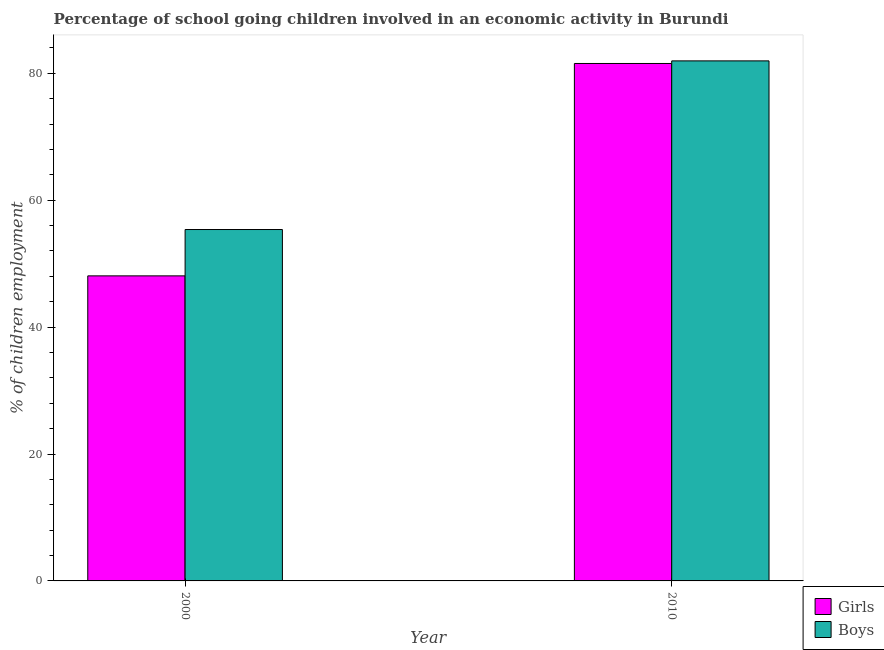How many different coloured bars are there?
Offer a terse response. 2. How many groups of bars are there?
Your answer should be very brief. 2. Are the number of bars on each tick of the X-axis equal?
Your response must be concise. Yes. How many bars are there on the 2nd tick from the left?
Give a very brief answer. 2. In how many cases, is the number of bars for a given year not equal to the number of legend labels?
Ensure brevity in your answer.  0. What is the percentage of school going boys in 2000?
Give a very brief answer. 55.38. Across all years, what is the maximum percentage of school going girls?
Make the answer very short. 81.54. Across all years, what is the minimum percentage of school going boys?
Offer a terse response. 55.38. What is the total percentage of school going boys in the graph?
Your response must be concise. 137.33. What is the difference between the percentage of school going girls in 2000 and that in 2010?
Your answer should be compact. -33.47. What is the difference between the percentage of school going boys in 2010 and the percentage of school going girls in 2000?
Your response must be concise. 26.58. What is the average percentage of school going girls per year?
Offer a terse response. 64.81. In how many years, is the percentage of school going girls greater than 44 %?
Provide a succinct answer. 2. What is the ratio of the percentage of school going girls in 2000 to that in 2010?
Your answer should be very brief. 0.59. What does the 1st bar from the left in 2000 represents?
Provide a short and direct response. Girls. What does the 2nd bar from the right in 2010 represents?
Offer a terse response. Girls. How many bars are there?
Offer a very short reply. 4. How many years are there in the graph?
Ensure brevity in your answer.  2. Are the values on the major ticks of Y-axis written in scientific E-notation?
Provide a short and direct response. No. Where does the legend appear in the graph?
Offer a terse response. Bottom right. What is the title of the graph?
Your response must be concise. Percentage of school going children involved in an economic activity in Burundi. Does "Girls" appear as one of the legend labels in the graph?
Offer a terse response. Yes. What is the label or title of the X-axis?
Keep it short and to the point. Year. What is the label or title of the Y-axis?
Provide a short and direct response. % of children employment. What is the % of children employment of Girls in 2000?
Ensure brevity in your answer.  48.07. What is the % of children employment in Boys in 2000?
Your answer should be compact. 55.38. What is the % of children employment in Girls in 2010?
Give a very brief answer. 81.54. What is the % of children employment in Boys in 2010?
Give a very brief answer. 81.96. Across all years, what is the maximum % of children employment of Girls?
Provide a short and direct response. 81.54. Across all years, what is the maximum % of children employment in Boys?
Offer a terse response. 81.96. Across all years, what is the minimum % of children employment in Girls?
Give a very brief answer. 48.07. Across all years, what is the minimum % of children employment of Boys?
Your response must be concise. 55.38. What is the total % of children employment of Girls in the graph?
Make the answer very short. 129.62. What is the total % of children employment in Boys in the graph?
Offer a very short reply. 137.33. What is the difference between the % of children employment in Girls in 2000 and that in 2010?
Keep it short and to the point. -33.47. What is the difference between the % of children employment of Boys in 2000 and that in 2010?
Make the answer very short. -26.58. What is the difference between the % of children employment of Girls in 2000 and the % of children employment of Boys in 2010?
Provide a short and direct response. -33.88. What is the average % of children employment in Girls per year?
Your answer should be compact. 64.81. What is the average % of children employment in Boys per year?
Give a very brief answer. 68.67. In the year 2000, what is the difference between the % of children employment in Girls and % of children employment in Boys?
Your answer should be very brief. -7.3. In the year 2010, what is the difference between the % of children employment in Girls and % of children employment in Boys?
Provide a succinct answer. -0.41. What is the ratio of the % of children employment of Girls in 2000 to that in 2010?
Ensure brevity in your answer.  0.59. What is the ratio of the % of children employment of Boys in 2000 to that in 2010?
Offer a very short reply. 0.68. What is the difference between the highest and the second highest % of children employment in Girls?
Ensure brevity in your answer.  33.47. What is the difference between the highest and the second highest % of children employment of Boys?
Offer a terse response. 26.58. What is the difference between the highest and the lowest % of children employment in Girls?
Your answer should be very brief. 33.47. What is the difference between the highest and the lowest % of children employment in Boys?
Keep it short and to the point. 26.58. 